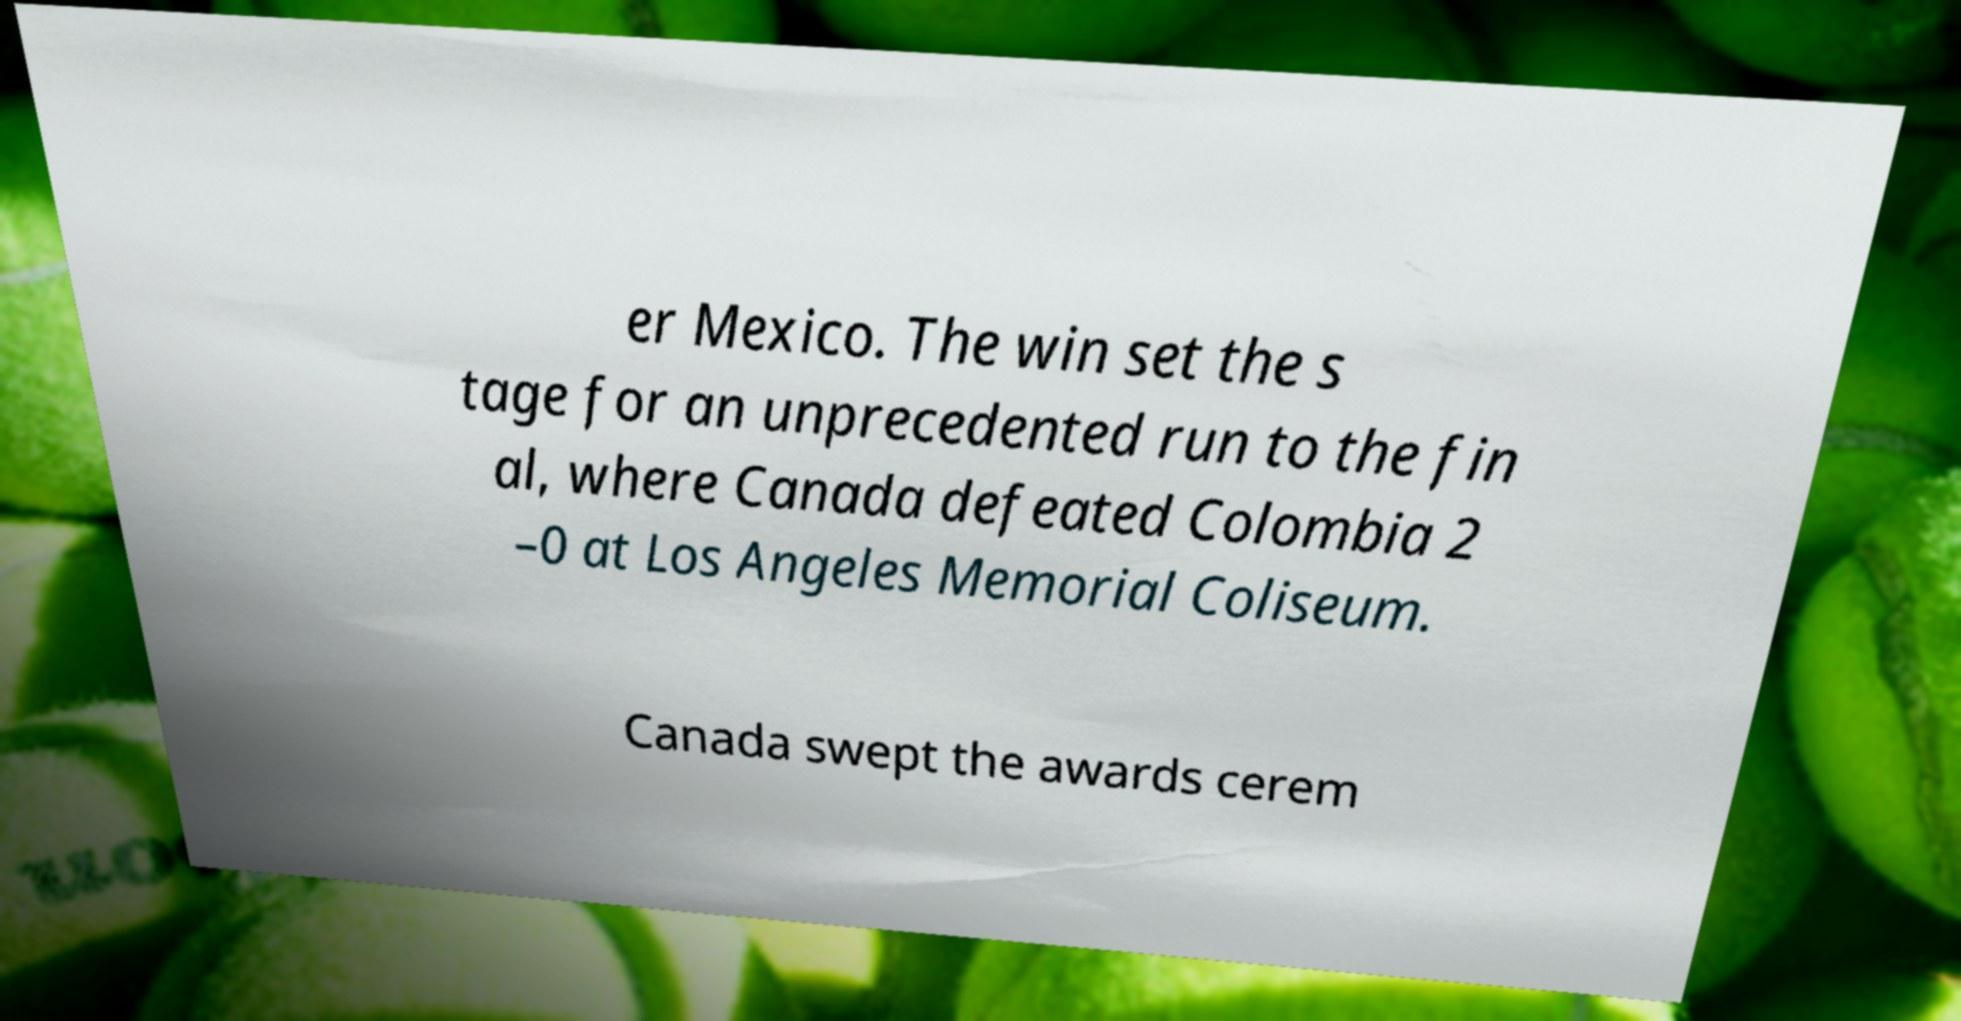There's text embedded in this image that I need extracted. Can you transcribe it verbatim? er Mexico. The win set the s tage for an unprecedented run to the fin al, where Canada defeated Colombia 2 –0 at Los Angeles Memorial Coliseum. Canada swept the awards cerem 